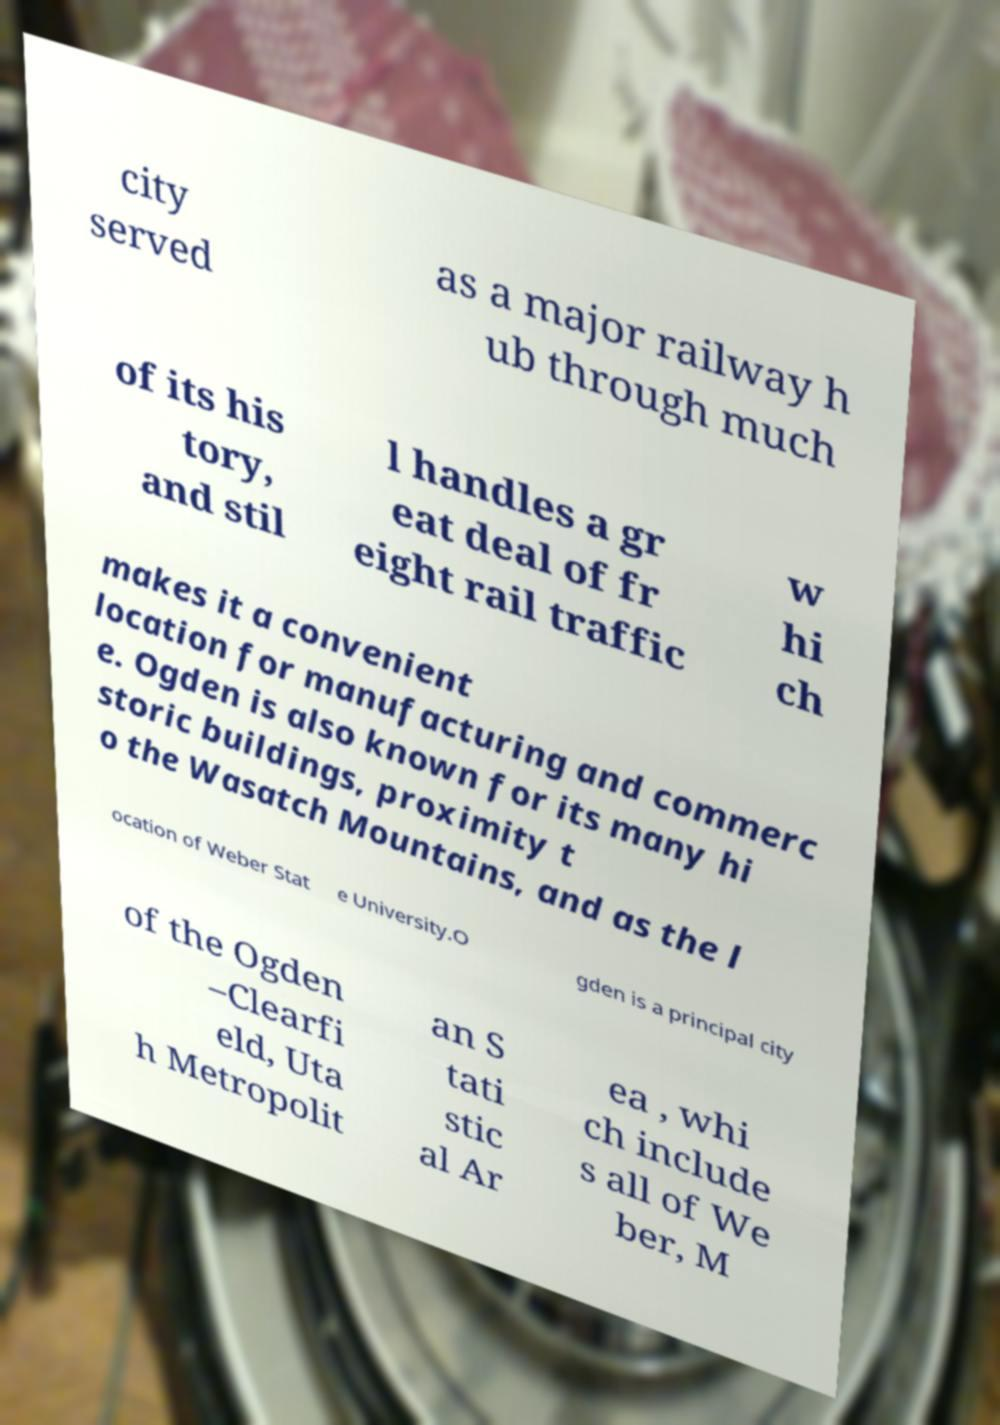Please identify and transcribe the text found in this image. city served as a major railway h ub through much of its his tory, and stil l handles a gr eat deal of fr eight rail traffic w hi ch makes it a convenient location for manufacturing and commerc e. Ogden is also known for its many hi storic buildings, proximity t o the Wasatch Mountains, and as the l ocation of Weber Stat e University.O gden is a principal city of the Ogden –Clearfi eld, Uta h Metropolit an S tati stic al Ar ea , whi ch include s all of We ber, M 